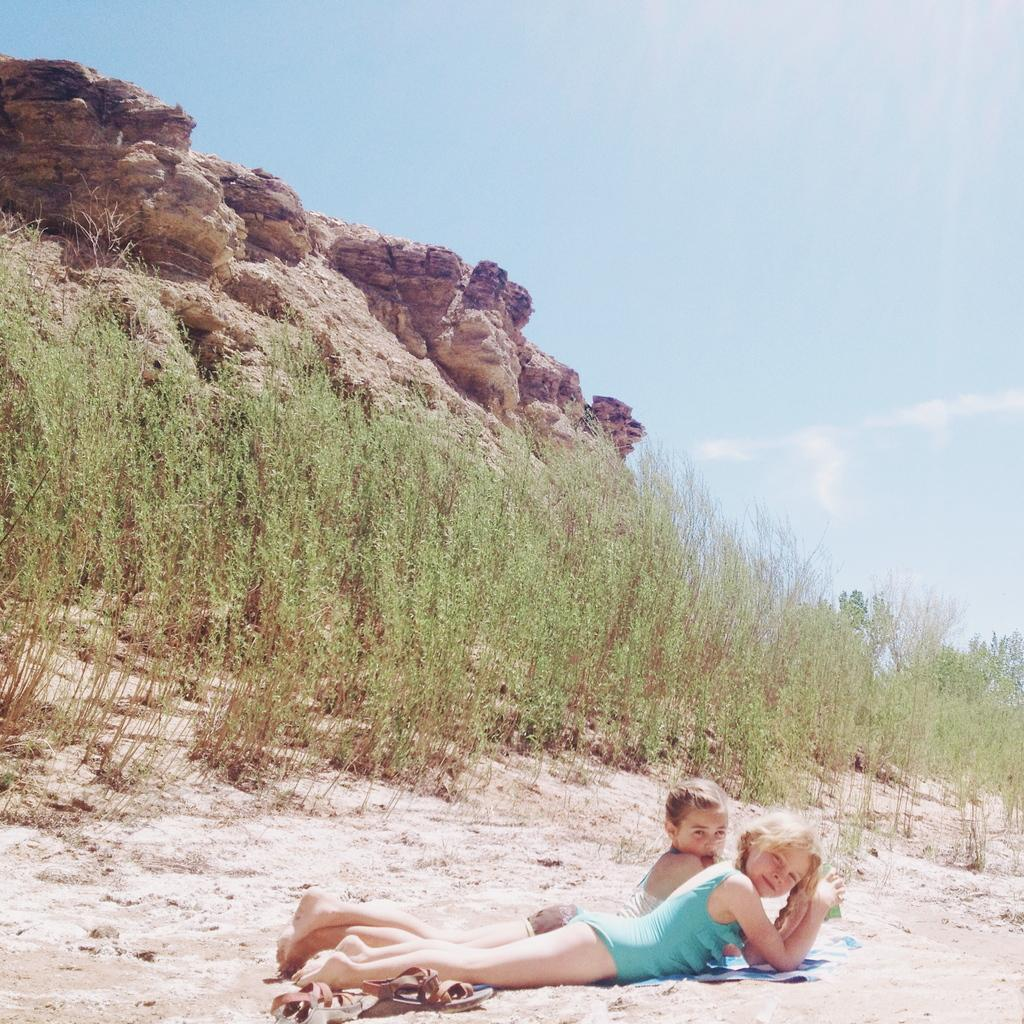What are the two girls doing in the image? The two girls are lying on the sand at the bottom of the image. What can be seen in the background of the image? There are rocks and plants in the background of the image. What is visible at the top of the image? The sky is visible at the top of the image. What type of bird can be seen flying in the aftermath of the image? There is no bird present in the image, nor is there any mention of an aftermath. 